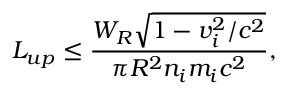<formula> <loc_0><loc_0><loc_500><loc_500>L _ { u p } \leq \frac { W _ { R } \sqrt { 1 - v _ { i } ^ { 2 } / c ^ { 2 } } } { \pi R ^ { 2 } n _ { i } m _ { i } c ^ { 2 } } ,</formula> 